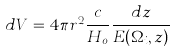<formula> <loc_0><loc_0><loc_500><loc_500>d V = 4 \pi r ^ { 2 } \frac { c } { H _ { o } } \frac { d z } { E ( \Omega _ { i } , z ) }</formula> 